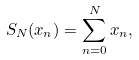<formula> <loc_0><loc_0><loc_500><loc_500>S _ { N } ( x _ { n } ) = \sum _ { n = 0 } ^ { N } { x _ { n } } ,</formula> 